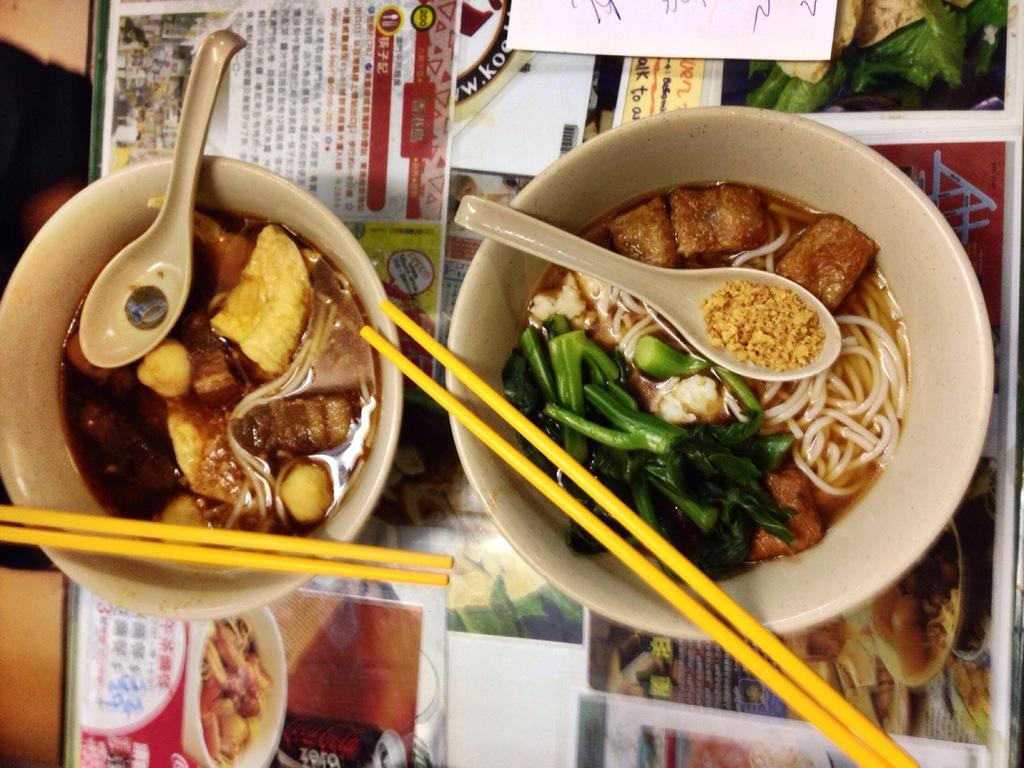How many bowls are in the image? There are two bowls in the image. What utensils are in the bowls? Chopsticks and spoons are visible in the bowls. What is the transparent object on the floor in the image? There is a floor glass in the image. What is placed on the floor glass? Papers are on the floor glass. What type of camera is being used to take a picture of the mice in the image? There are no mice or cameras present in the image. What type of drink is being served in the bowls? The bowls contain chopsticks and spoons, not drinks. 